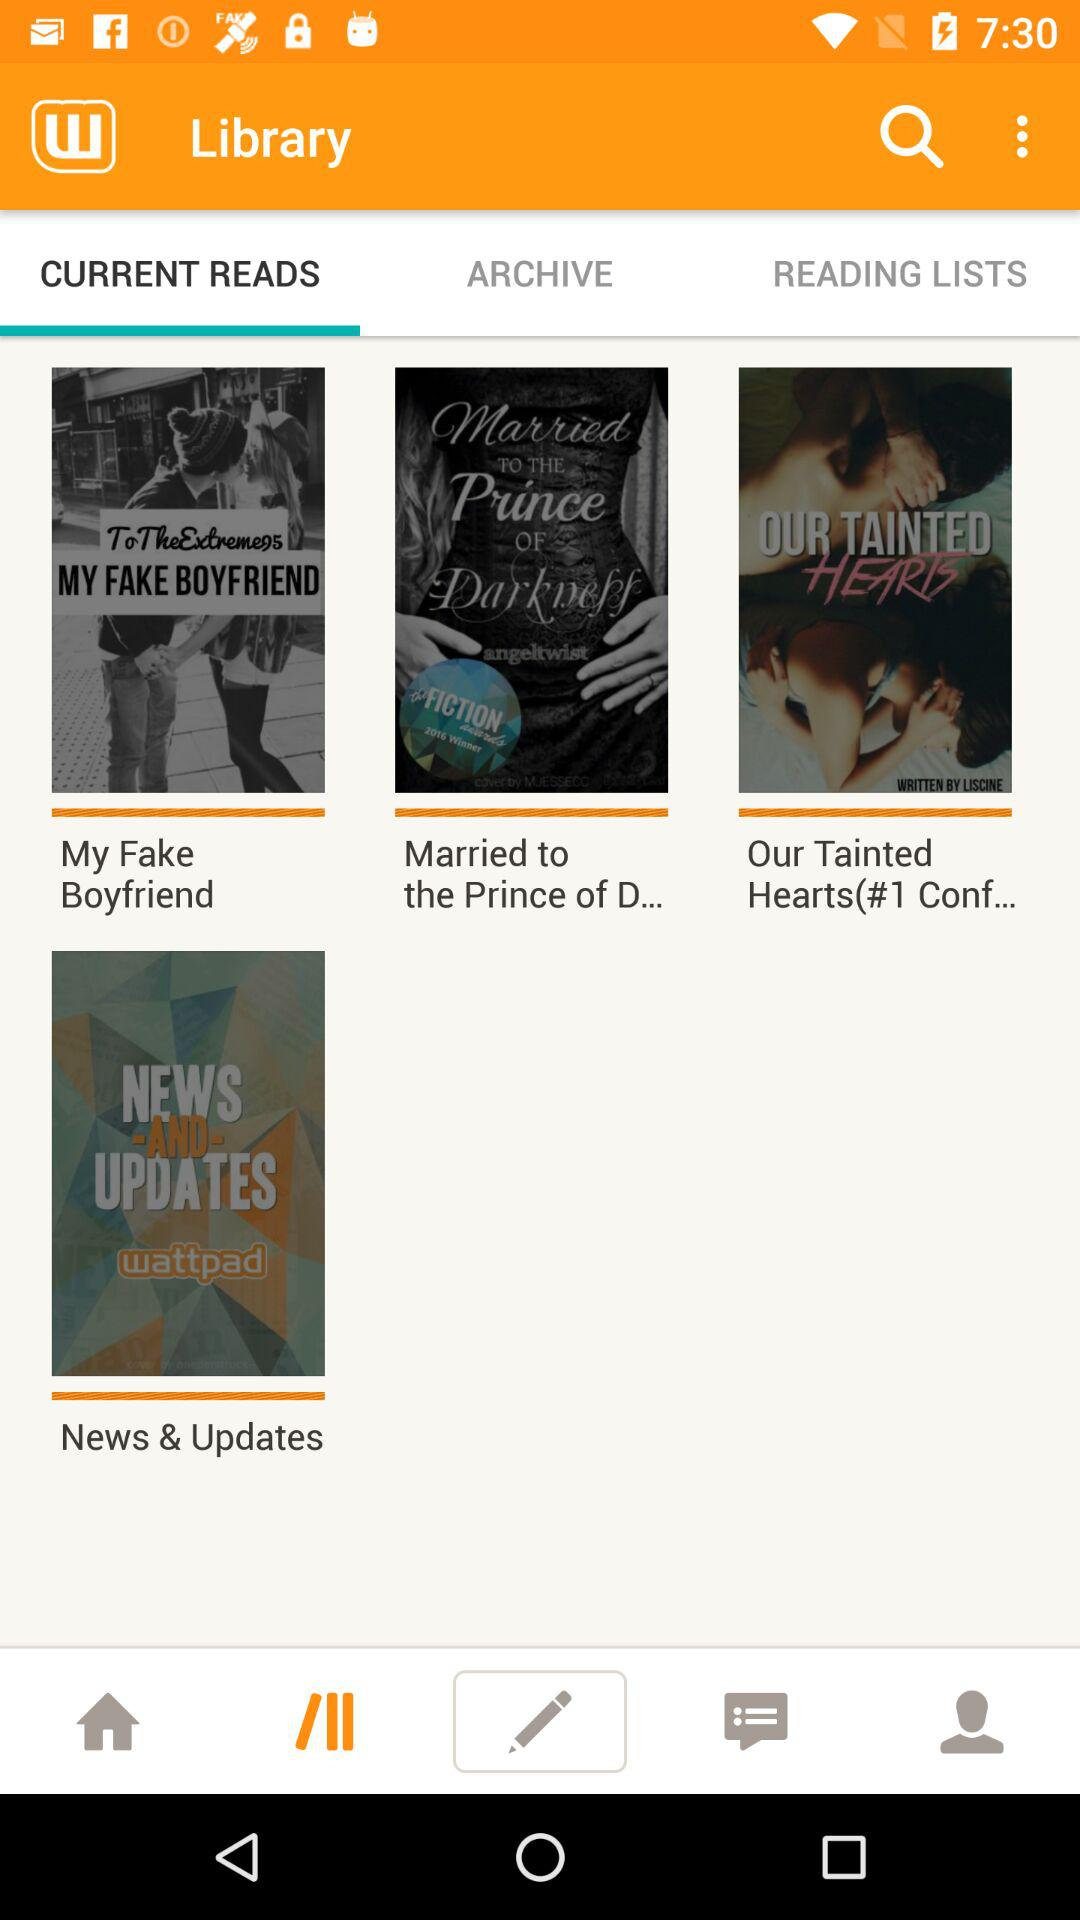Which tab am I on? You are on the tabs "Library" and "CURRENT READS". 